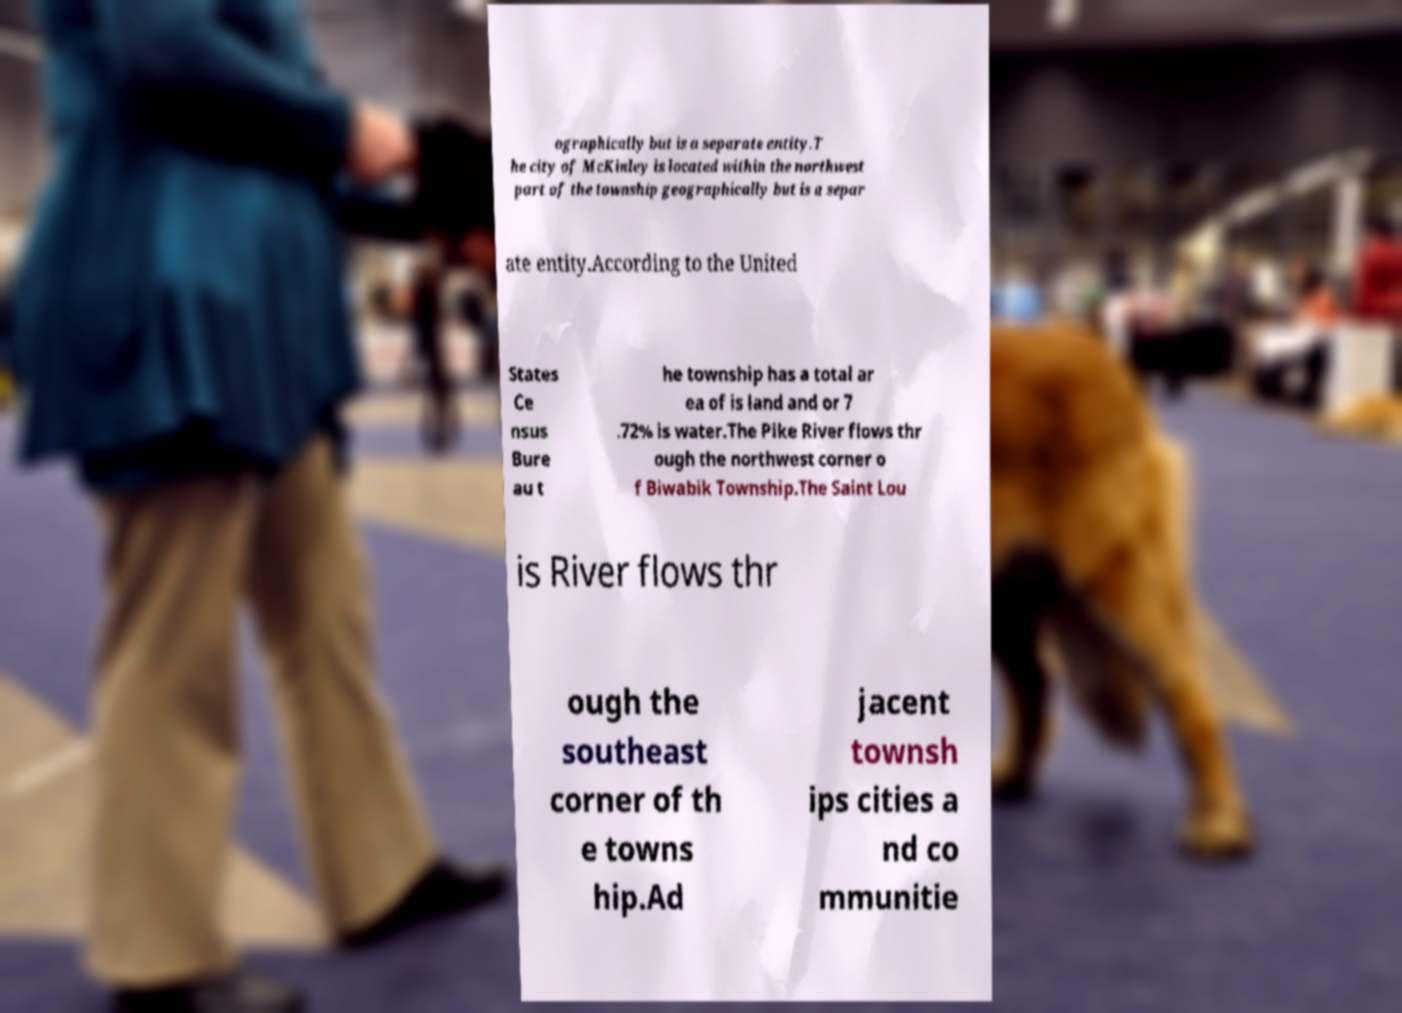Can you accurately transcribe the text from the provided image for me? ographically but is a separate entity.T he city of McKinley is located within the northwest part of the township geographically but is a separ ate entity.According to the United States Ce nsus Bure au t he township has a total ar ea of is land and or 7 .72% is water.The Pike River flows thr ough the northwest corner o f Biwabik Township.The Saint Lou is River flows thr ough the southeast corner of th e towns hip.Ad jacent townsh ips cities a nd co mmunitie 